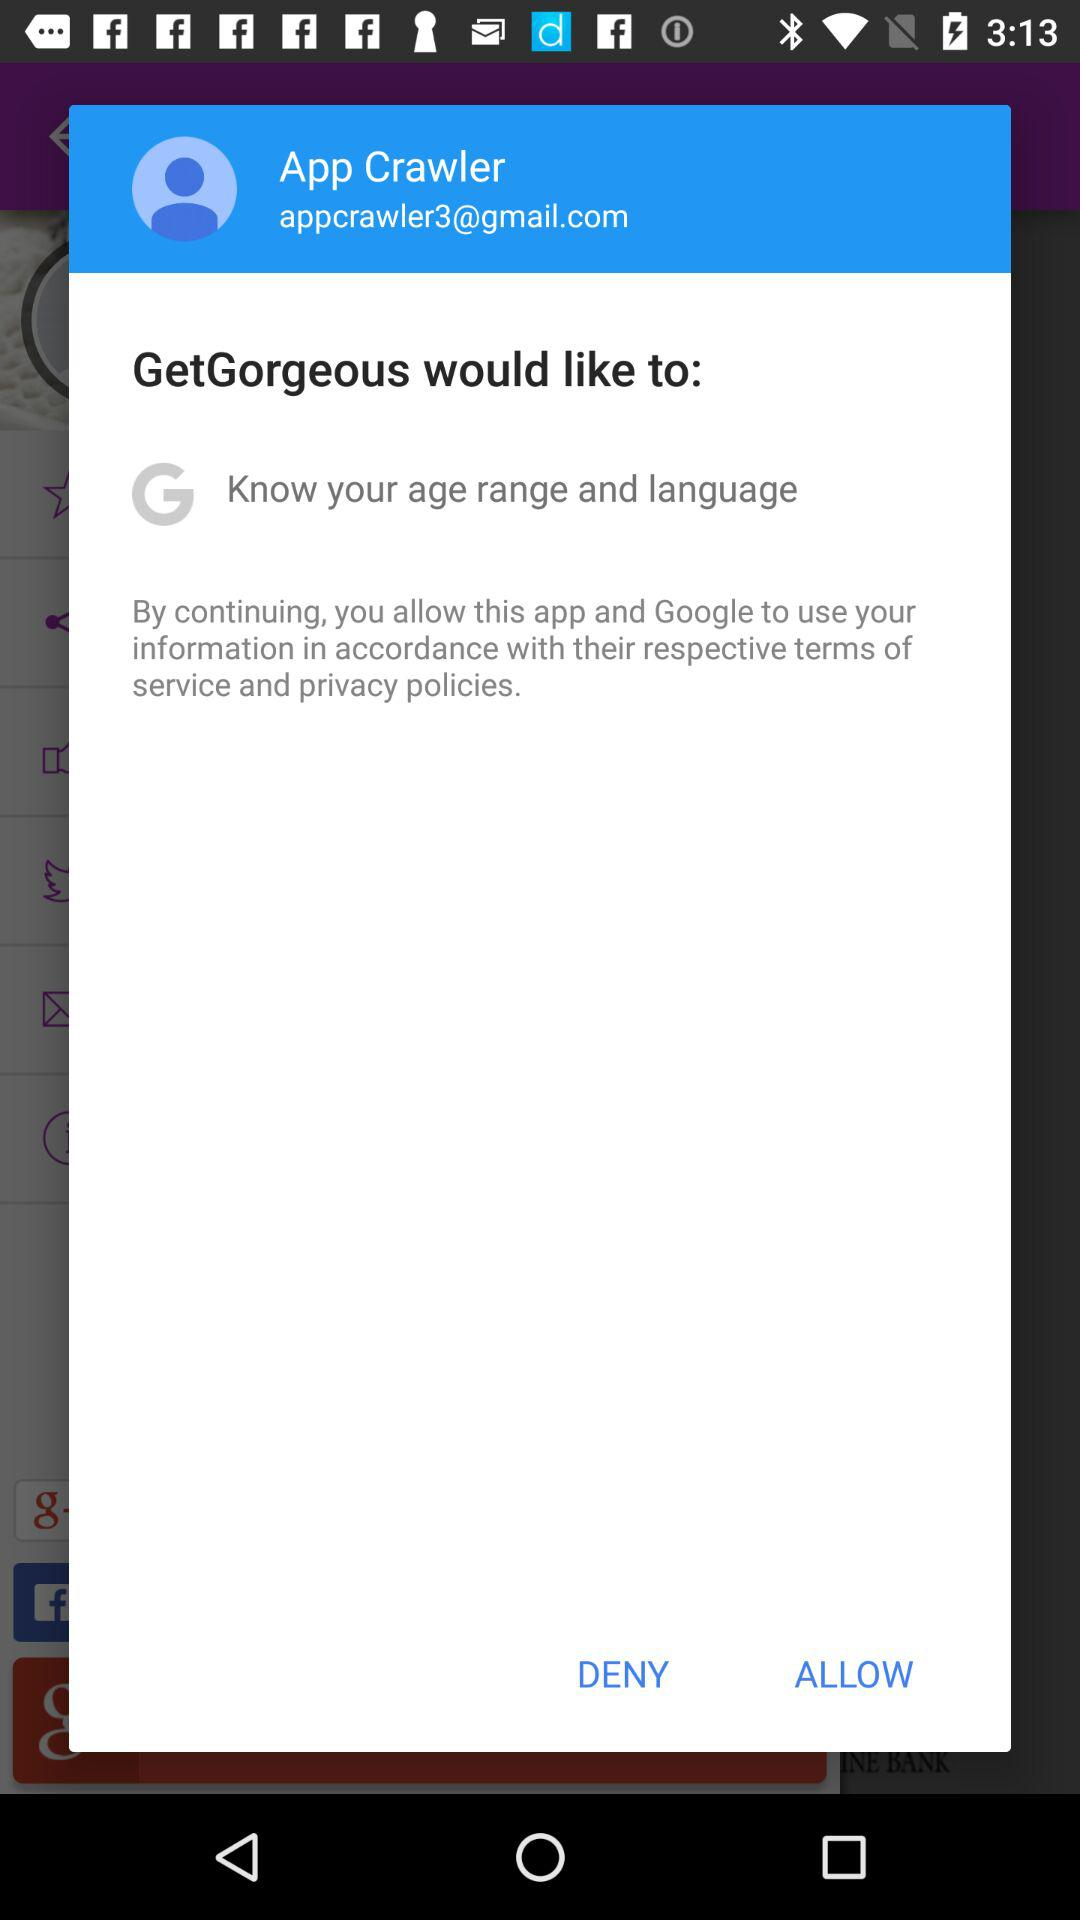What is the email ID of the user? The email ID of the user is appcrawler3@gmail.com. 